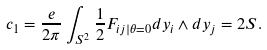<formula> <loc_0><loc_0><loc_500><loc_500>c _ { 1 } = \frac { e } { 2 \pi } \int _ { S ^ { 2 } } \frac { 1 } { 2 } F _ { i j | \theta = 0 } d y _ { i } \wedge d y _ { j } = 2 S .</formula> 